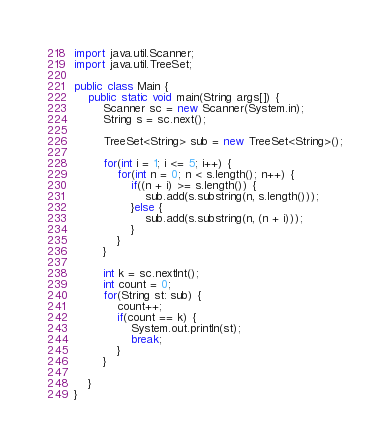Convert code to text. <code><loc_0><loc_0><loc_500><loc_500><_Java_>import java.util.Scanner;
import java.util.TreeSet;

public class Main {
	public static void main(String args[]) {
		Scanner sc = new Scanner(System.in);
		String s = sc.next();
		
		TreeSet<String> sub = new TreeSet<String>();
		
		for(int i = 1; i <= 5; i++) {
			for(int n = 0; n < s.length(); n++) {
				if((n + i) >= s.length()) {
					sub.add(s.substring(n, s.length()));
				}else {
					sub.add(s.substring(n, (n + i)));
				}
			}
		}
		
		int k = sc.nextInt();
		int count = 0;
		for(String st: sub) {
			count++;
			if(count == k) {
				System.out.println(st);
				break;
			}
		}
		
	}
}</code> 